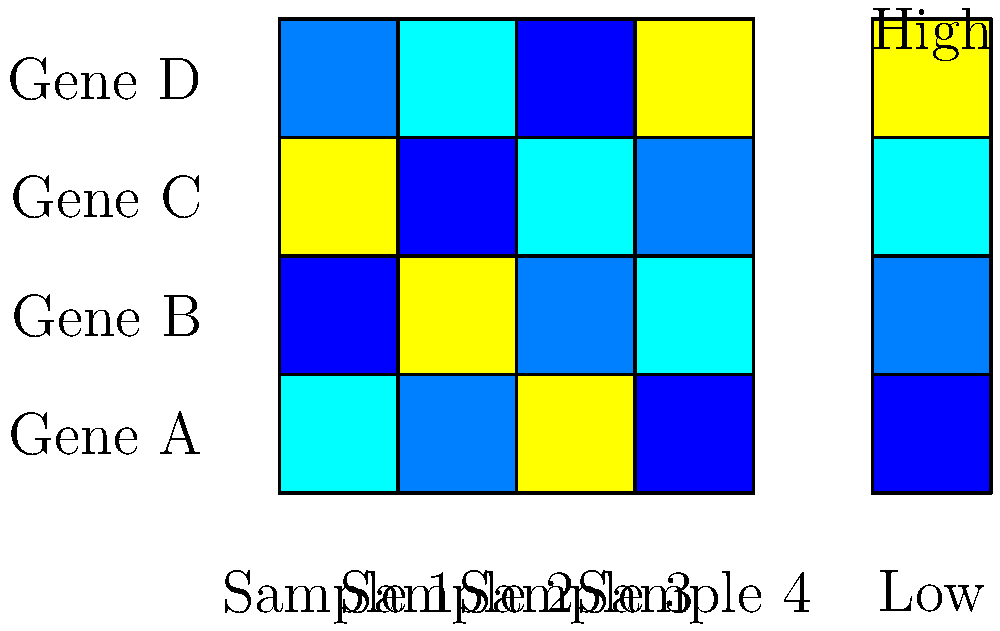In the given heatmap of gene expression levels, which gene shows the highest expression in Sample 3? To determine which gene shows the highest expression in Sample 3, we need to follow these steps:

1. Identify Sample 3 on the heatmap:
   Sample 3 is the third column from the left.

2. Examine the color intensity for each gene in Sample 3:
   - Gene A (top row): Light blue (medium-low expression)
   - Gene B (second row): Dark blue (low expression)
   - Gene C (third row): Yellow (high expression)
   - Gene D (bottom row): Light blue (medium-low expression)

3. Compare the color intensities:
   The color scale on the right shows that yellow represents the highest expression level, while dark blue represents the lowest.

4. Identify the gene with the highest expression:
   In Sample 3, Gene C has the yellow color, indicating the highest expression level among all genes in this sample.

Therefore, Gene C shows the highest expression in Sample 3.
Answer: Gene C 